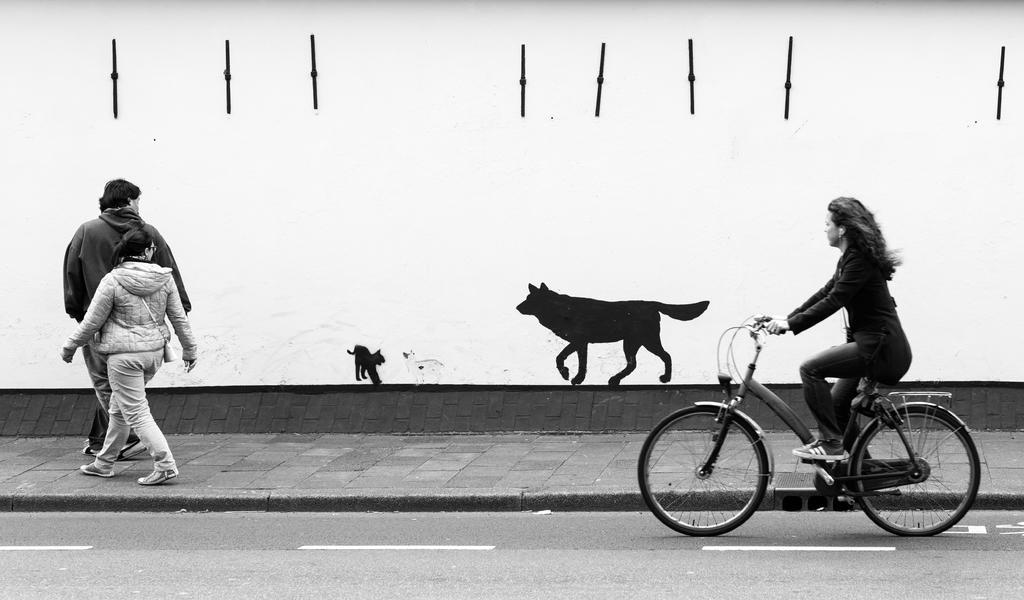Describe this image in one or two sentences. Bottom left side of the image two persons are walking. Bottom right side of the image a woman is riding bicycle on the road. In the middle of the image there is a paint on the wall. 